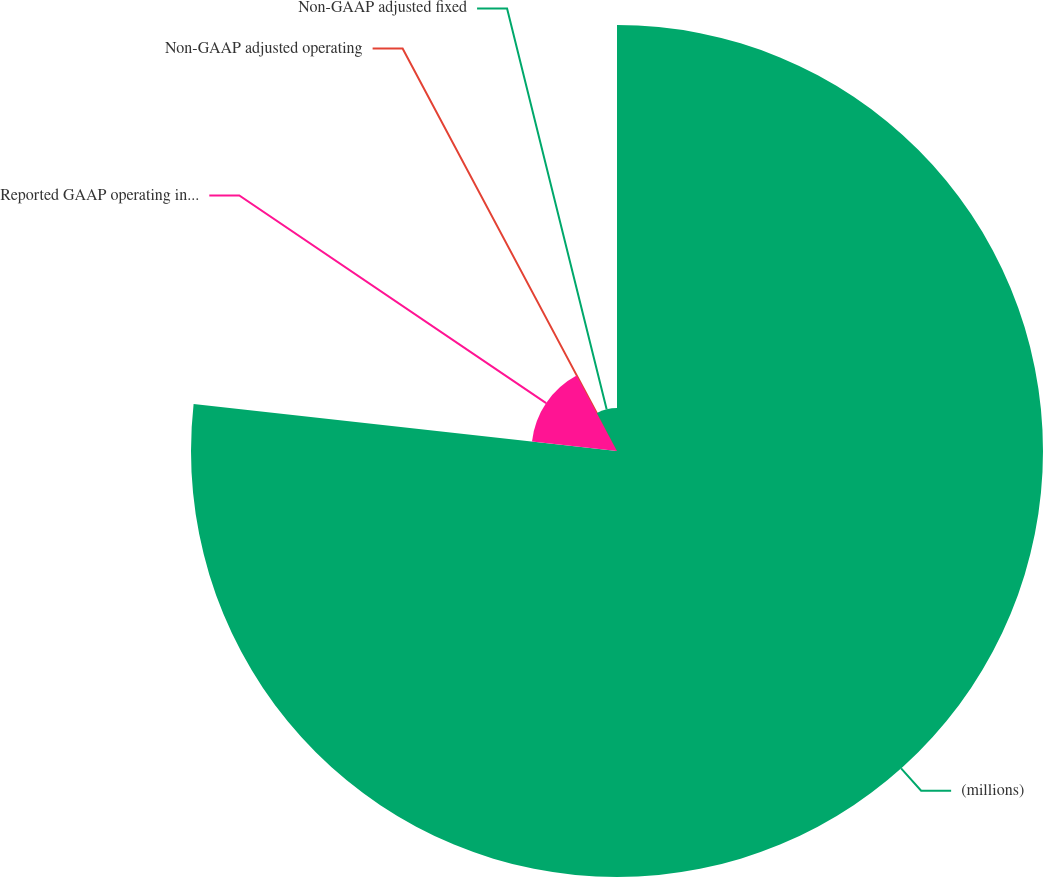Convert chart. <chart><loc_0><loc_0><loc_500><loc_500><pie_chart><fcel>(millions)<fcel>Reported GAAP operating income<fcel>Non-GAAP adjusted operating<fcel>Non-GAAP adjusted fixed<nl><fcel>76.76%<fcel>15.41%<fcel>0.08%<fcel>7.75%<nl></chart> 